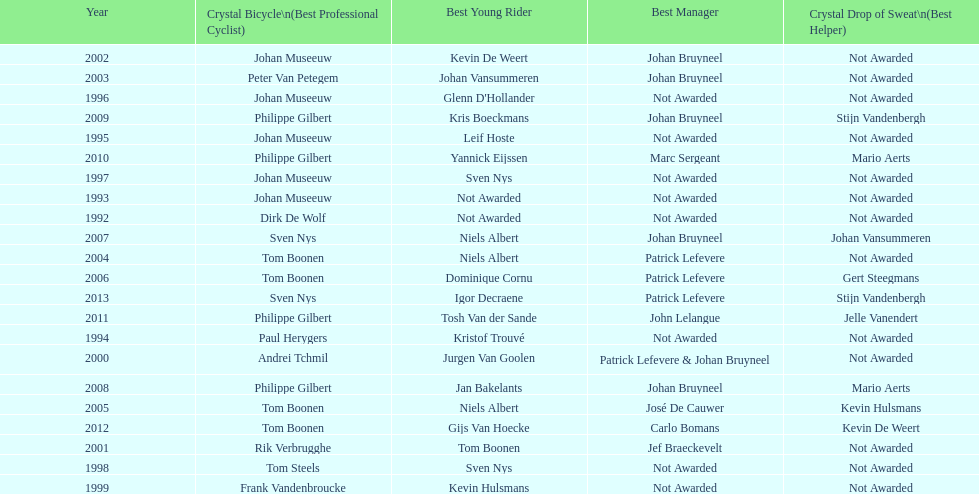What is the average number of times johan museeuw starred? 5. 